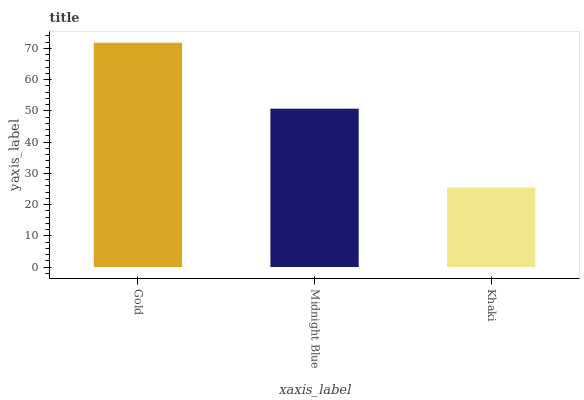Is Khaki the minimum?
Answer yes or no. Yes. Is Gold the maximum?
Answer yes or no. Yes. Is Midnight Blue the minimum?
Answer yes or no. No. Is Midnight Blue the maximum?
Answer yes or no. No. Is Gold greater than Midnight Blue?
Answer yes or no. Yes. Is Midnight Blue less than Gold?
Answer yes or no. Yes. Is Midnight Blue greater than Gold?
Answer yes or no. No. Is Gold less than Midnight Blue?
Answer yes or no. No. Is Midnight Blue the high median?
Answer yes or no. Yes. Is Midnight Blue the low median?
Answer yes or no. Yes. Is Gold the high median?
Answer yes or no. No. Is Gold the low median?
Answer yes or no. No. 